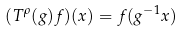Convert formula to latex. <formula><loc_0><loc_0><loc_500><loc_500>( T ^ { \rho } ( g ) f ) ( x ) = f ( g ^ { - 1 } x )</formula> 